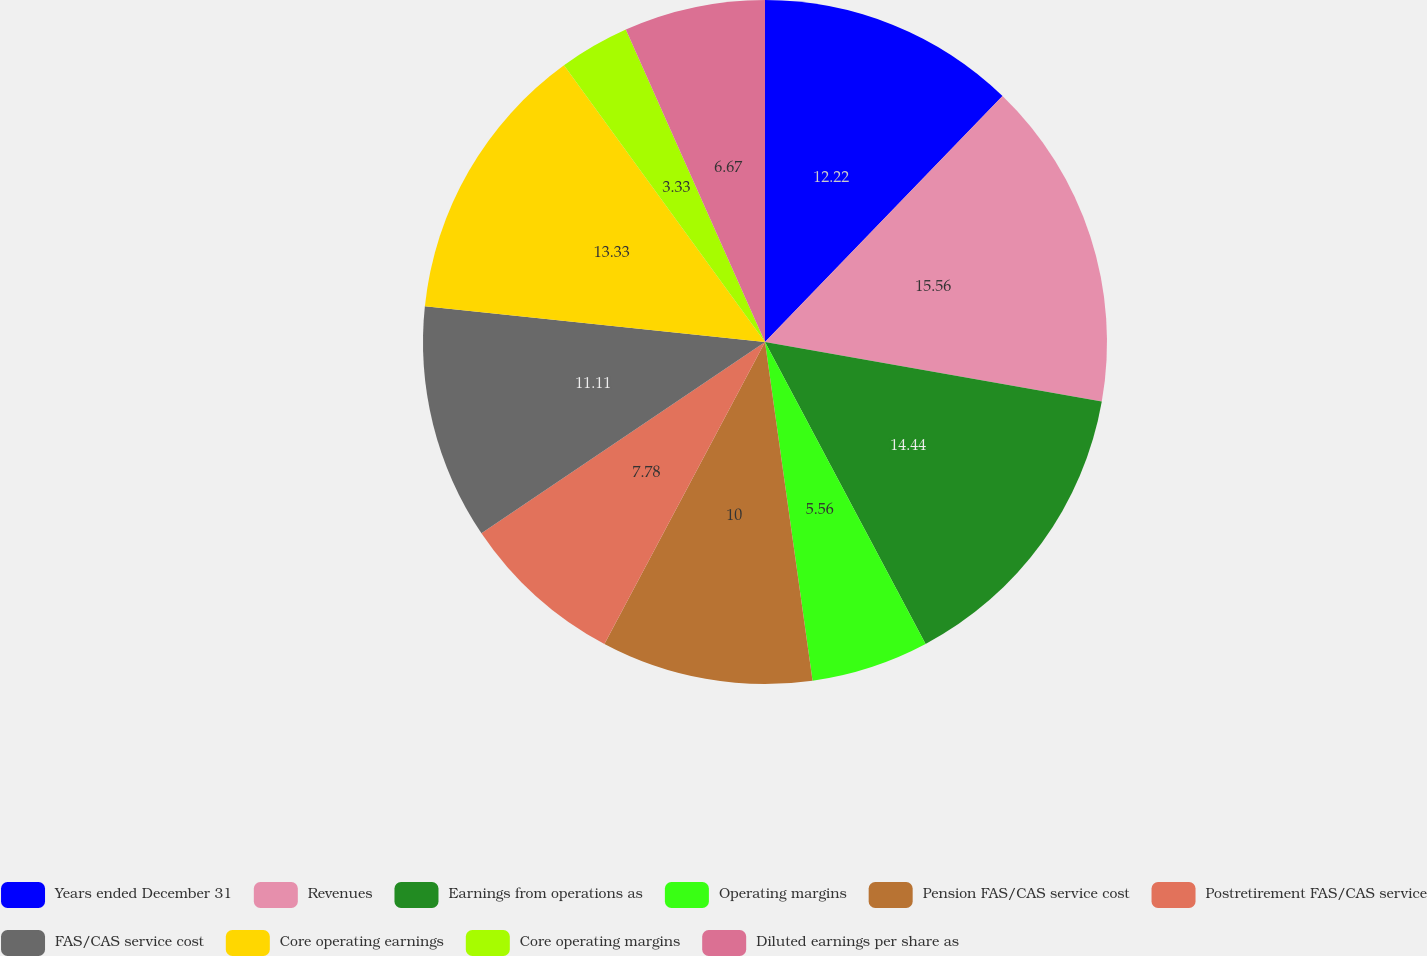Convert chart to OTSL. <chart><loc_0><loc_0><loc_500><loc_500><pie_chart><fcel>Years ended December 31<fcel>Revenues<fcel>Earnings from operations as<fcel>Operating margins<fcel>Pension FAS/CAS service cost<fcel>Postretirement FAS/CAS service<fcel>FAS/CAS service cost<fcel>Core operating earnings<fcel>Core operating margins<fcel>Diluted earnings per share as<nl><fcel>12.22%<fcel>15.56%<fcel>14.44%<fcel>5.56%<fcel>10.0%<fcel>7.78%<fcel>11.11%<fcel>13.33%<fcel>3.33%<fcel>6.67%<nl></chart> 